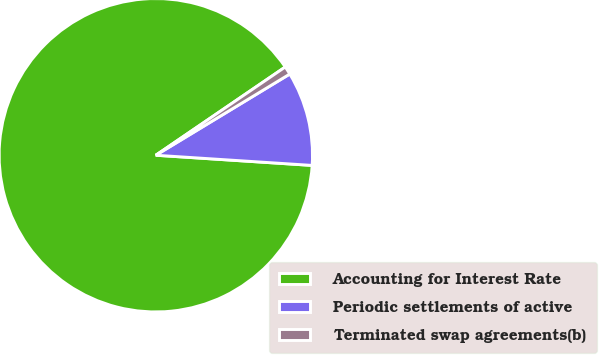Convert chart. <chart><loc_0><loc_0><loc_500><loc_500><pie_chart><fcel>Accounting for Interest Rate<fcel>Periodic settlements of active<fcel>Terminated swap agreements(b)<nl><fcel>89.45%<fcel>9.71%<fcel>0.85%<nl></chart> 